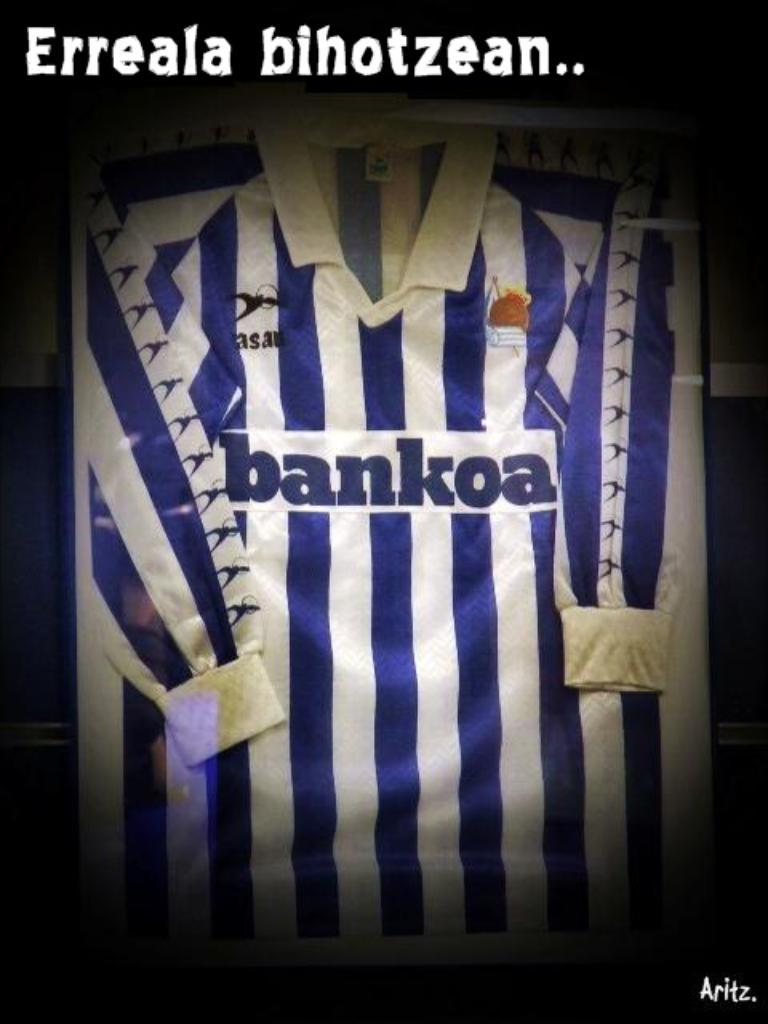Provide a one-sentence caption for the provided image. A sports shirt with blue and white stripes that reads "bankoa.". 